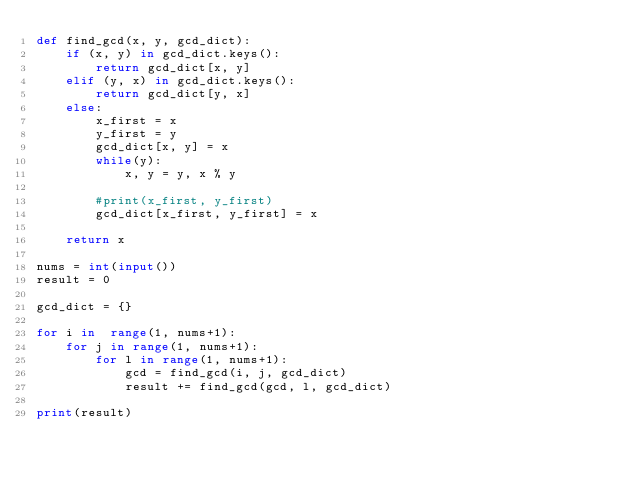Convert code to text. <code><loc_0><loc_0><loc_500><loc_500><_Python_>def find_gcd(x, y, gcd_dict):
    if (x, y) in gcd_dict.keys():
        return gcd_dict[x, y]
    elif (y, x) in gcd_dict.keys():
        return gcd_dict[y, x]
    else:
        x_first = x
        y_first = y
        gcd_dict[x, y] = x
        while(y): 
            x, y = y, x % y 

        #print(x_first, y_first)
        gcd_dict[x_first, y_first] = x

    return x

nums = int(input())
result = 0

gcd_dict = {}

for i in  range(1, nums+1):
    for j in range(1, nums+1):
        for l in range(1, nums+1):
            gcd = find_gcd(i, j, gcd_dict)
            result += find_gcd(gcd, l, gcd_dict)

print(result)</code> 